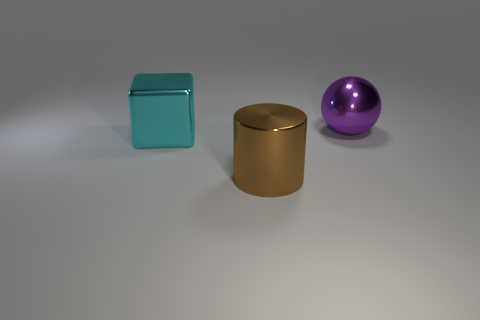Add 2 tiny yellow cubes. How many objects exist? 5 Subtract all balls. How many objects are left? 2 Subtract all blocks. Subtract all big purple spheres. How many objects are left? 1 Add 1 cyan things. How many cyan things are left? 2 Add 1 small green cylinders. How many small green cylinders exist? 1 Subtract 1 brown cylinders. How many objects are left? 2 